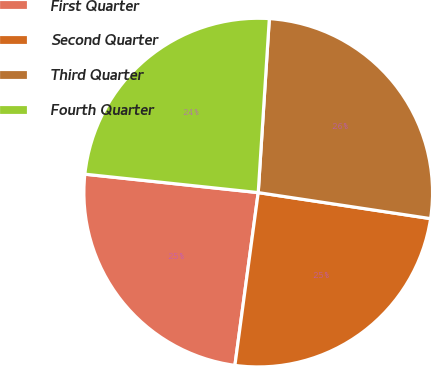Convert chart. <chart><loc_0><loc_0><loc_500><loc_500><pie_chart><fcel>First Quarter<fcel>Second Quarter<fcel>Third Quarter<fcel>Fourth Quarter<nl><fcel>24.55%<fcel>24.75%<fcel>26.37%<fcel>24.33%<nl></chart> 